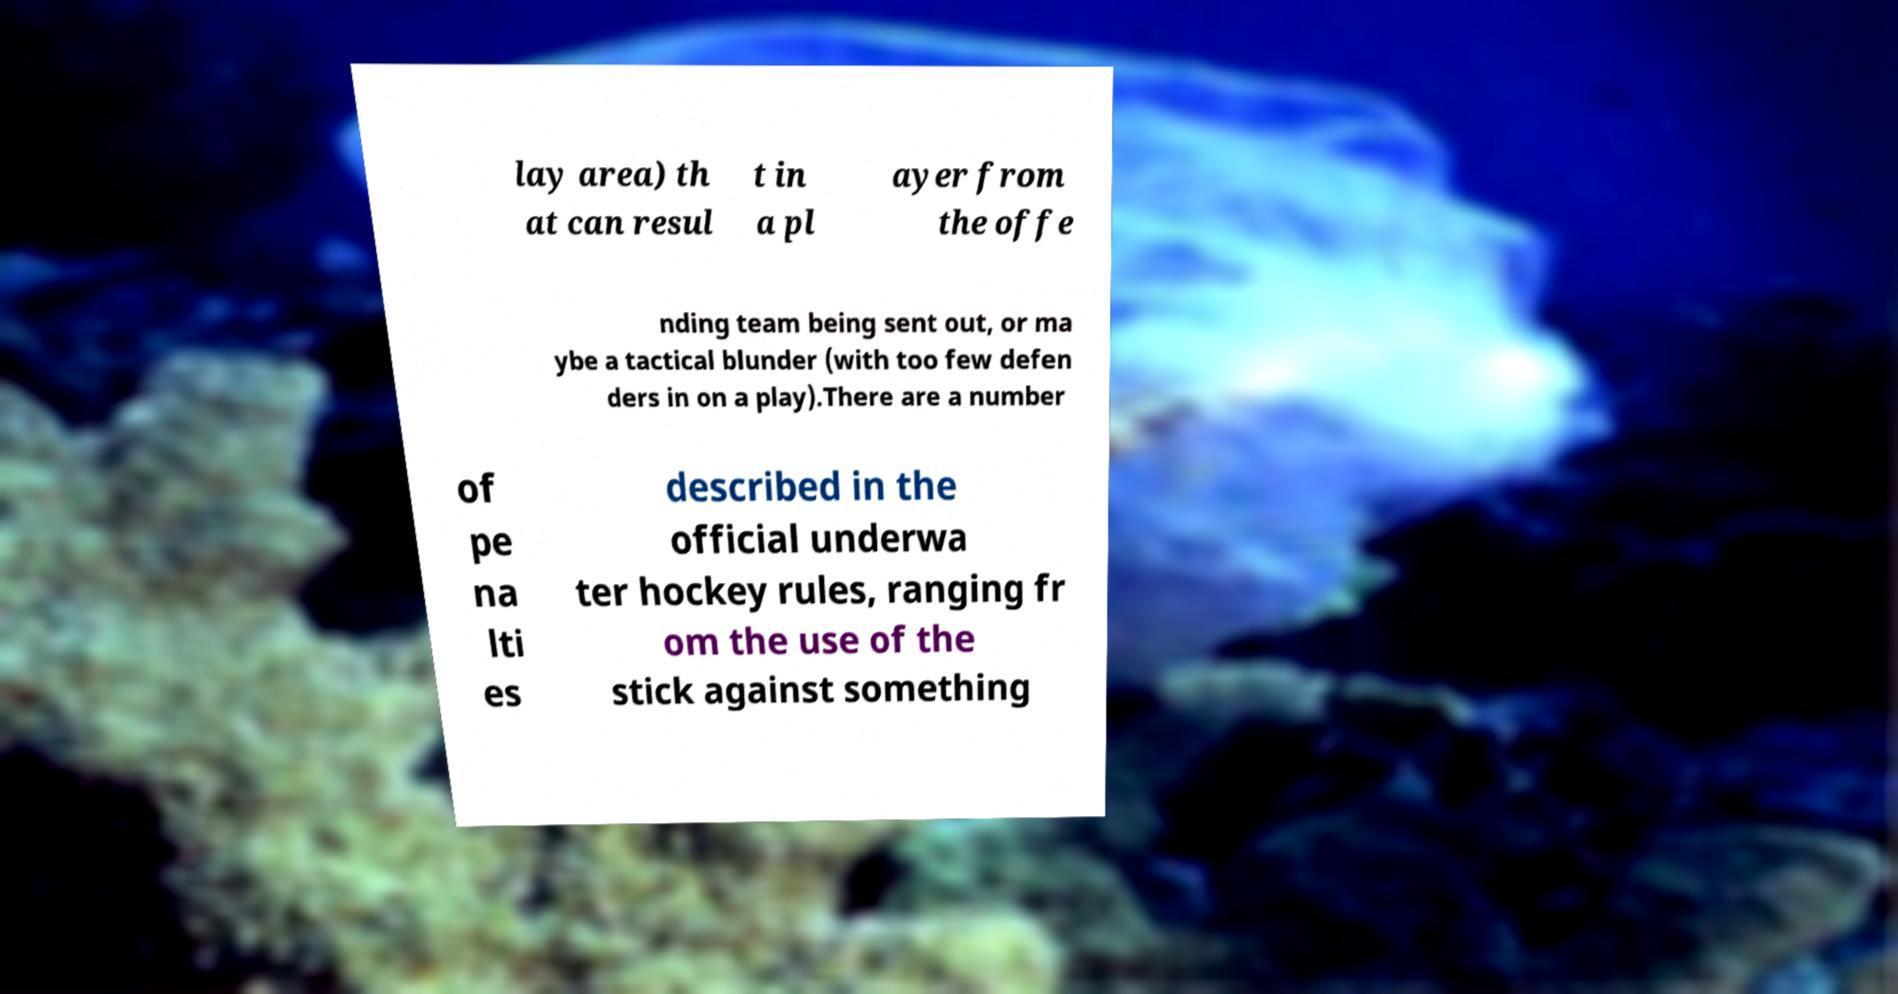For documentation purposes, I need the text within this image transcribed. Could you provide that? lay area) th at can resul t in a pl ayer from the offe nding team being sent out, or ma ybe a tactical blunder (with too few defen ders in on a play).There are a number of pe na lti es described in the official underwa ter hockey rules, ranging fr om the use of the stick against something 